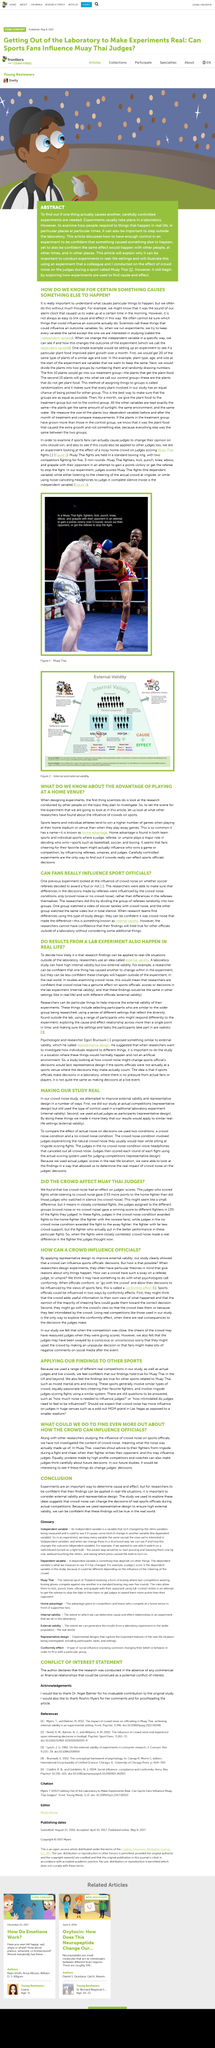Identify some key points in this picture. Yes, the decision-making process for sports officials at a live event is similar to that in a laboratory. Scientists use variables in experiments by manipulating one variable while keeping all other variables constant except the one of interest (the independent variable). The temporal and spatial regulations of Muay Thai fights are established in a standard boxing ring, with two competitors engaging in a fierce battle over the course of five 3-minute rounds. Fans cheering for their favorite team may influence referees, umpires, and judges. Yes, crowd noise can significantly impact an official's decision-making. 